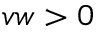<formula> <loc_0><loc_0><loc_500><loc_500>v w > 0</formula> 